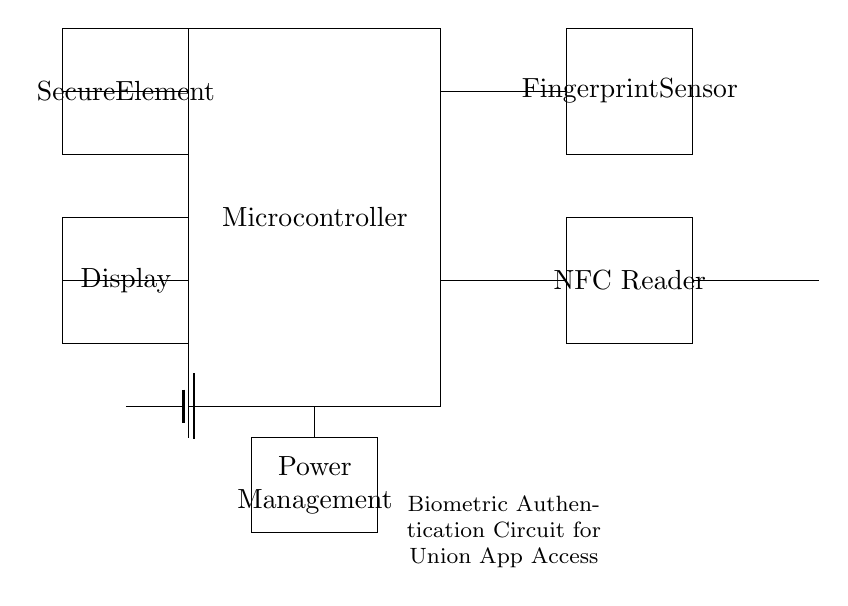What component is connected to the fingerprint sensor? The fingerprint sensor has a direct connection to the microcontroller, as indicated by the horizontal line connecting them.
Answer: Microcontroller What is the function of the secure element? The secure element is used for safely processing and storing sensitive data related to biometric authentication. This is inferred from its function in circuits dealing with security.
Answer: Safe storage How many main functional components are there in this circuit? The circuit contains five main components: Microcontroller, Fingerprint Sensor, NFC Reader, Secure Element, and Power Management. This count is derived from visually identifying each individual rectangular block in the diagram.
Answer: Five What does the antenna in the circuit signify? The antenna indicates features related to wireless communication, likely for accessing network resources or securely transmitting data. This can be deduced from its presence, which is common in mobile devices for connectivity.
Answer: Wireless communication What is the output connection of the power management system? The power management system directly connects to the microcontroller, supplying power necessary for the operation of the device, which is indicated by the connection line extending from it.
Answer: Microcontroller How is the fingerprint sensor powered in the circuit? The fingerprint sensor is powered through the microcontroller, which acts as a power distributor by sharing electrical supply among the components connected to it, including the fingerprint sensor.
Answer: Through the microcontroller 